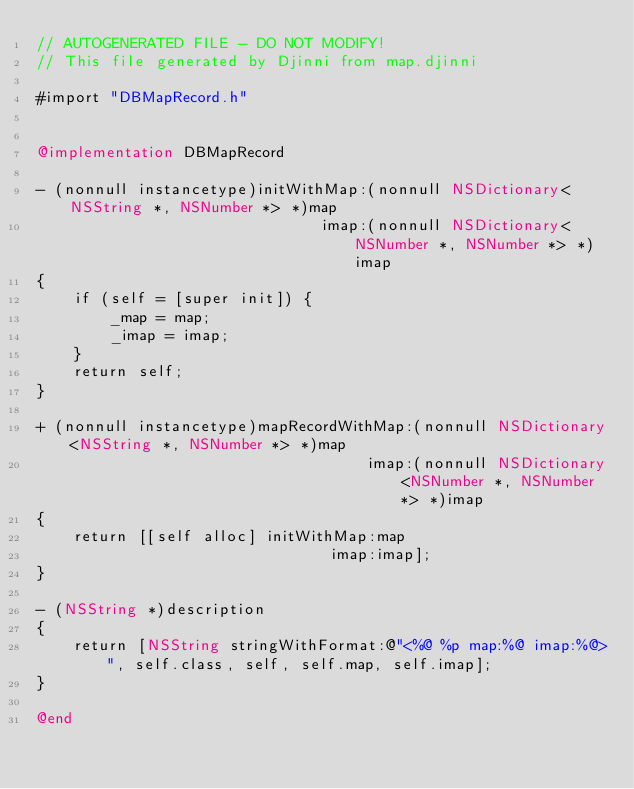<code> <loc_0><loc_0><loc_500><loc_500><_ObjectiveC_>// AUTOGENERATED FILE - DO NOT MODIFY!
// This file generated by Djinni from map.djinni

#import "DBMapRecord.h"


@implementation DBMapRecord

- (nonnull instancetype)initWithMap:(nonnull NSDictionary<NSString *, NSNumber *> *)map
                               imap:(nonnull NSDictionary<NSNumber *, NSNumber *> *)imap
{
    if (self = [super init]) {
        _map = map;
        _imap = imap;
    }
    return self;
}

+ (nonnull instancetype)mapRecordWithMap:(nonnull NSDictionary<NSString *, NSNumber *> *)map
                                    imap:(nonnull NSDictionary<NSNumber *, NSNumber *> *)imap
{
    return [[self alloc] initWithMap:map
                                imap:imap];
}

- (NSString *)description
{
    return [NSString stringWithFormat:@"<%@ %p map:%@ imap:%@>", self.class, self, self.map, self.imap];
}

@end
</code> 